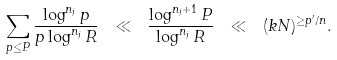Convert formula to latex. <formula><loc_0><loc_0><loc_500><loc_500>\sum _ { p \leq P } \frac { \log ^ { n _ { j } } p } { p \log ^ { n _ { j } } R } \ \ll \ \frac { \log ^ { n _ { j } + 1 } P } { \log ^ { n _ { j } } R } \ \ll \ ( k N ) ^ { \geq p ^ { \prime } / n } .</formula> 